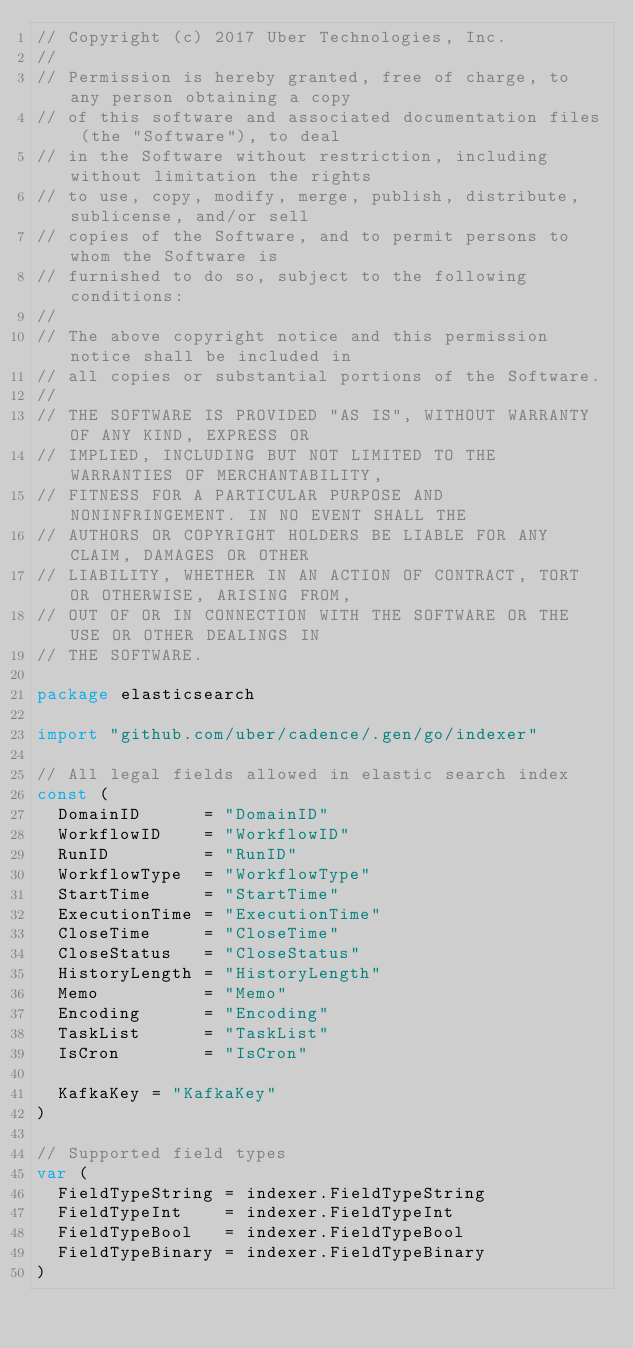<code> <loc_0><loc_0><loc_500><loc_500><_Go_>// Copyright (c) 2017 Uber Technologies, Inc.
//
// Permission is hereby granted, free of charge, to any person obtaining a copy
// of this software and associated documentation files (the "Software"), to deal
// in the Software without restriction, including without limitation the rights
// to use, copy, modify, merge, publish, distribute, sublicense, and/or sell
// copies of the Software, and to permit persons to whom the Software is
// furnished to do so, subject to the following conditions:
//
// The above copyright notice and this permission notice shall be included in
// all copies or substantial portions of the Software.
//
// THE SOFTWARE IS PROVIDED "AS IS", WITHOUT WARRANTY OF ANY KIND, EXPRESS OR
// IMPLIED, INCLUDING BUT NOT LIMITED TO THE WARRANTIES OF MERCHANTABILITY,
// FITNESS FOR A PARTICULAR PURPOSE AND NONINFRINGEMENT. IN NO EVENT SHALL THE
// AUTHORS OR COPYRIGHT HOLDERS BE LIABLE FOR ANY CLAIM, DAMAGES OR OTHER
// LIABILITY, WHETHER IN AN ACTION OF CONTRACT, TORT OR OTHERWISE, ARISING FROM,
// OUT OF OR IN CONNECTION WITH THE SOFTWARE OR THE USE OR OTHER DEALINGS IN
// THE SOFTWARE.

package elasticsearch

import "github.com/uber/cadence/.gen/go/indexer"

// All legal fields allowed in elastic search index
const (
	DomainID      = "DomainID"
	WorkflowID    = "WorkflowID"
	RunID         = "RunID"
	WorkflowType  = "WorkflowType"
	StartTime     = "StartTime"
	ExecutionTime = "ExecutionTime"
	CloseTime     = "CloseTime"
	CloseStatus   = "CloseStatus"
	HistoryLength = "HistoryLength"
	Memo          = "Memo"
	Encoding      = "Encoding"
	TaskList      = "TaskList"
	IsCron        = "IsCron"

	KafkaKey = "KafkaKey"
)

// Supported field types
var (
	FieldTypeString = indexer.FieldTypeString
	FieldTypeInt    = indexer.FieldTypeInt
	FieldTypeBool   = indexer.FieldTypeBool
	FieldTypeBinary = indexer.FieldTypeBinary
)
</code> 